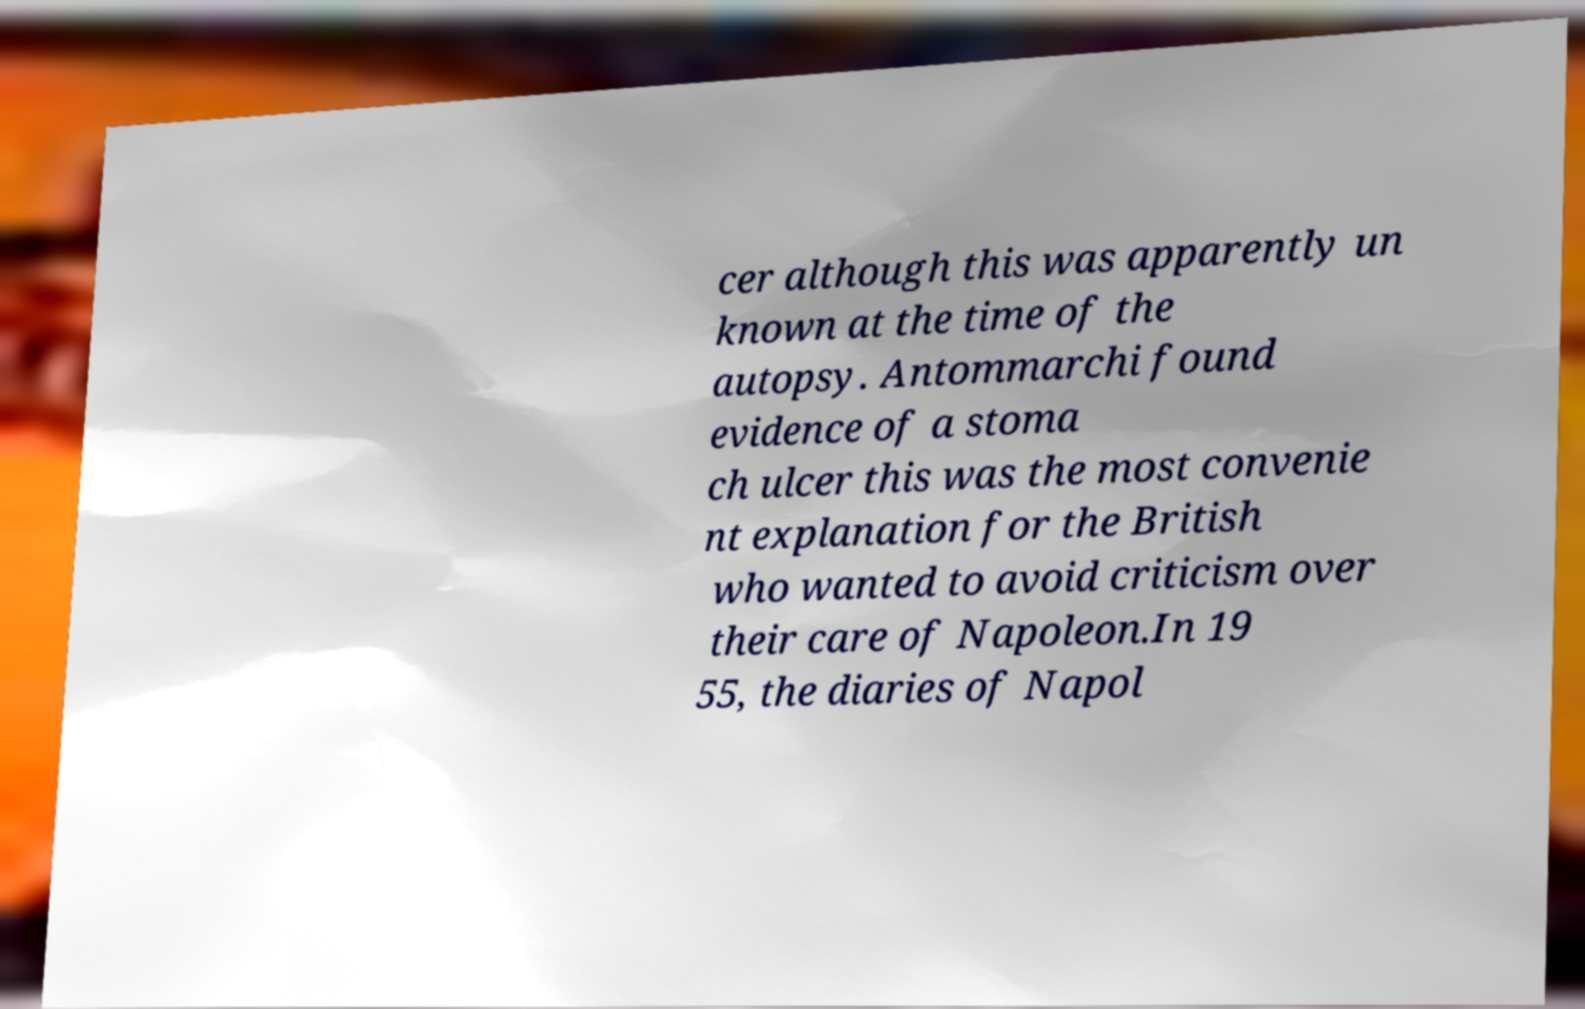Please identify and transcribe the text found in this image. cer although this was apparently un known at the time of the autopsy. Antommarchi found evidence of a stoma ch ulcer this was the most convenie nt explanation for the British who wanted to avoid criticism over their care of Napoleon.In 19 55, the diaries of Napol 